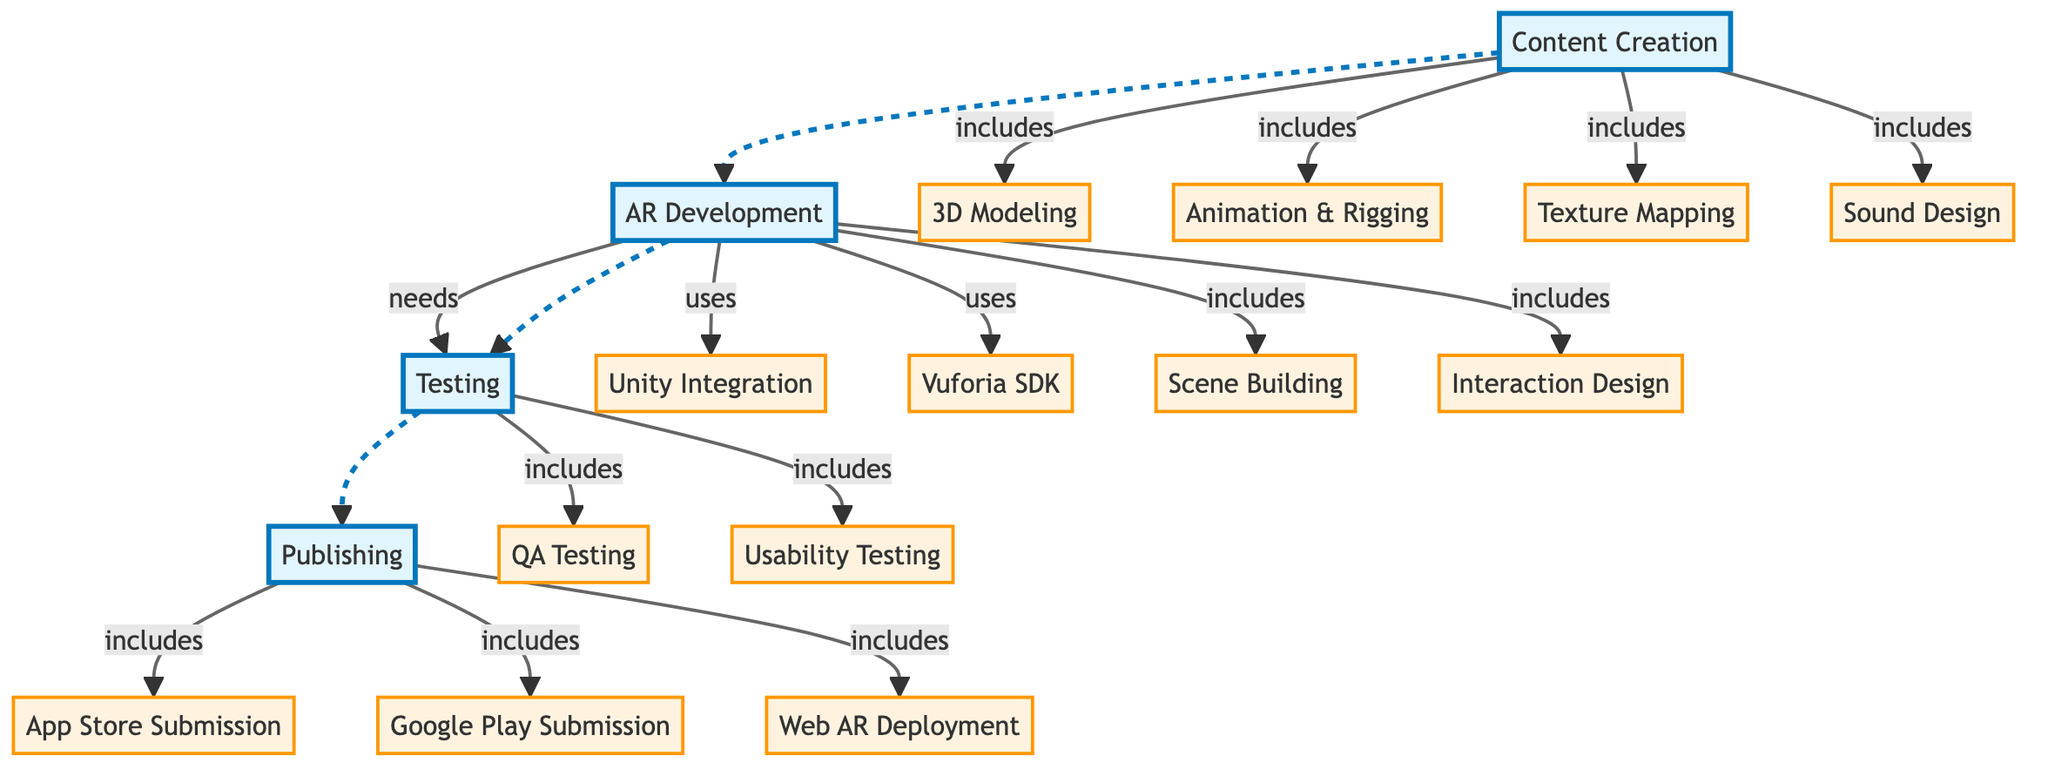What are the main steps involved in the AR content creation process? The diagram outlines four main steps in the AR content creation process: Content Creation, AR Development, Testing, and Publishing. Each of these steps includes specific activities or tools that contribute to the overall workflow.
Answer: Content Creation, AR Development, Testing, Publishing How many subnodes are under Content Creation? The diagram lists four subnodes under Content Creation: 3D Modeling, Animation & Rigging, Texture Mapping, and Sound Design. Counting these gives a total of four subnodes.
Answer: 4 Which tool is specifically mentioned for AR Development? The diagram indicates two specific tools for AR Development: Unity Integration and Vuforia SDK. The question asks for a tool, and any one of these tools can be the answer.
Answer: Unity Integration or Vuforia SDK What relationship exists between Testing and Publishing? The diagram shows that Testing leads into the Publishing step, indicating a sequence in the workflow where Testing must occur before Publishing is initiated.
Answer: Testing leads to Publishing What types of testing are included in the Testing step? The Testing step consists of two types of testing: QA Testing and Usability Testing. These are the activities detailed as part of the Testing phase.
Answer: QA Testing, Usability Testing What happens after AR Development? According to the diagram, after AR Development is the Testing phase. This is indicated by the directional flow from AR Development to Testing.
Answer: Testing Which subnode under Publishing does not require any additional tools or processes? The diagram lists three subnodes under Publishing: App Store Submission, Google Play Submission, and Web AR Deployment. All three relate directly to publishing processes, without any indications of tools or further prerequisites.
Answer: App Store Submission, Google Play Submission, or Web AR Deployment How does content creation relate to AR Development? The diagram indicates a dashed line from Content Creation to AR Development, suggesting that while these phases are related, the content creation process is not directly dependent on AR Development and may occur independently.
Answer: Related but independent How many edges connect the Testing phase to its subnodes? The Testing phase has two subnodes connected to it: QA Testing and Usability Testing. Each of these connections represents an edge, resulting in two edges in total.
Answer: 2 What is the sequence of steps to follow after AR Development? According to the diagram, the sequence following AR Development is: Testing, and then Publishing, indicating the workflow's progression.
Answer: Testing, then Publishing 